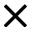<formula> <loc_0><loc_0><loc_500><loc_500>\times</formula> 